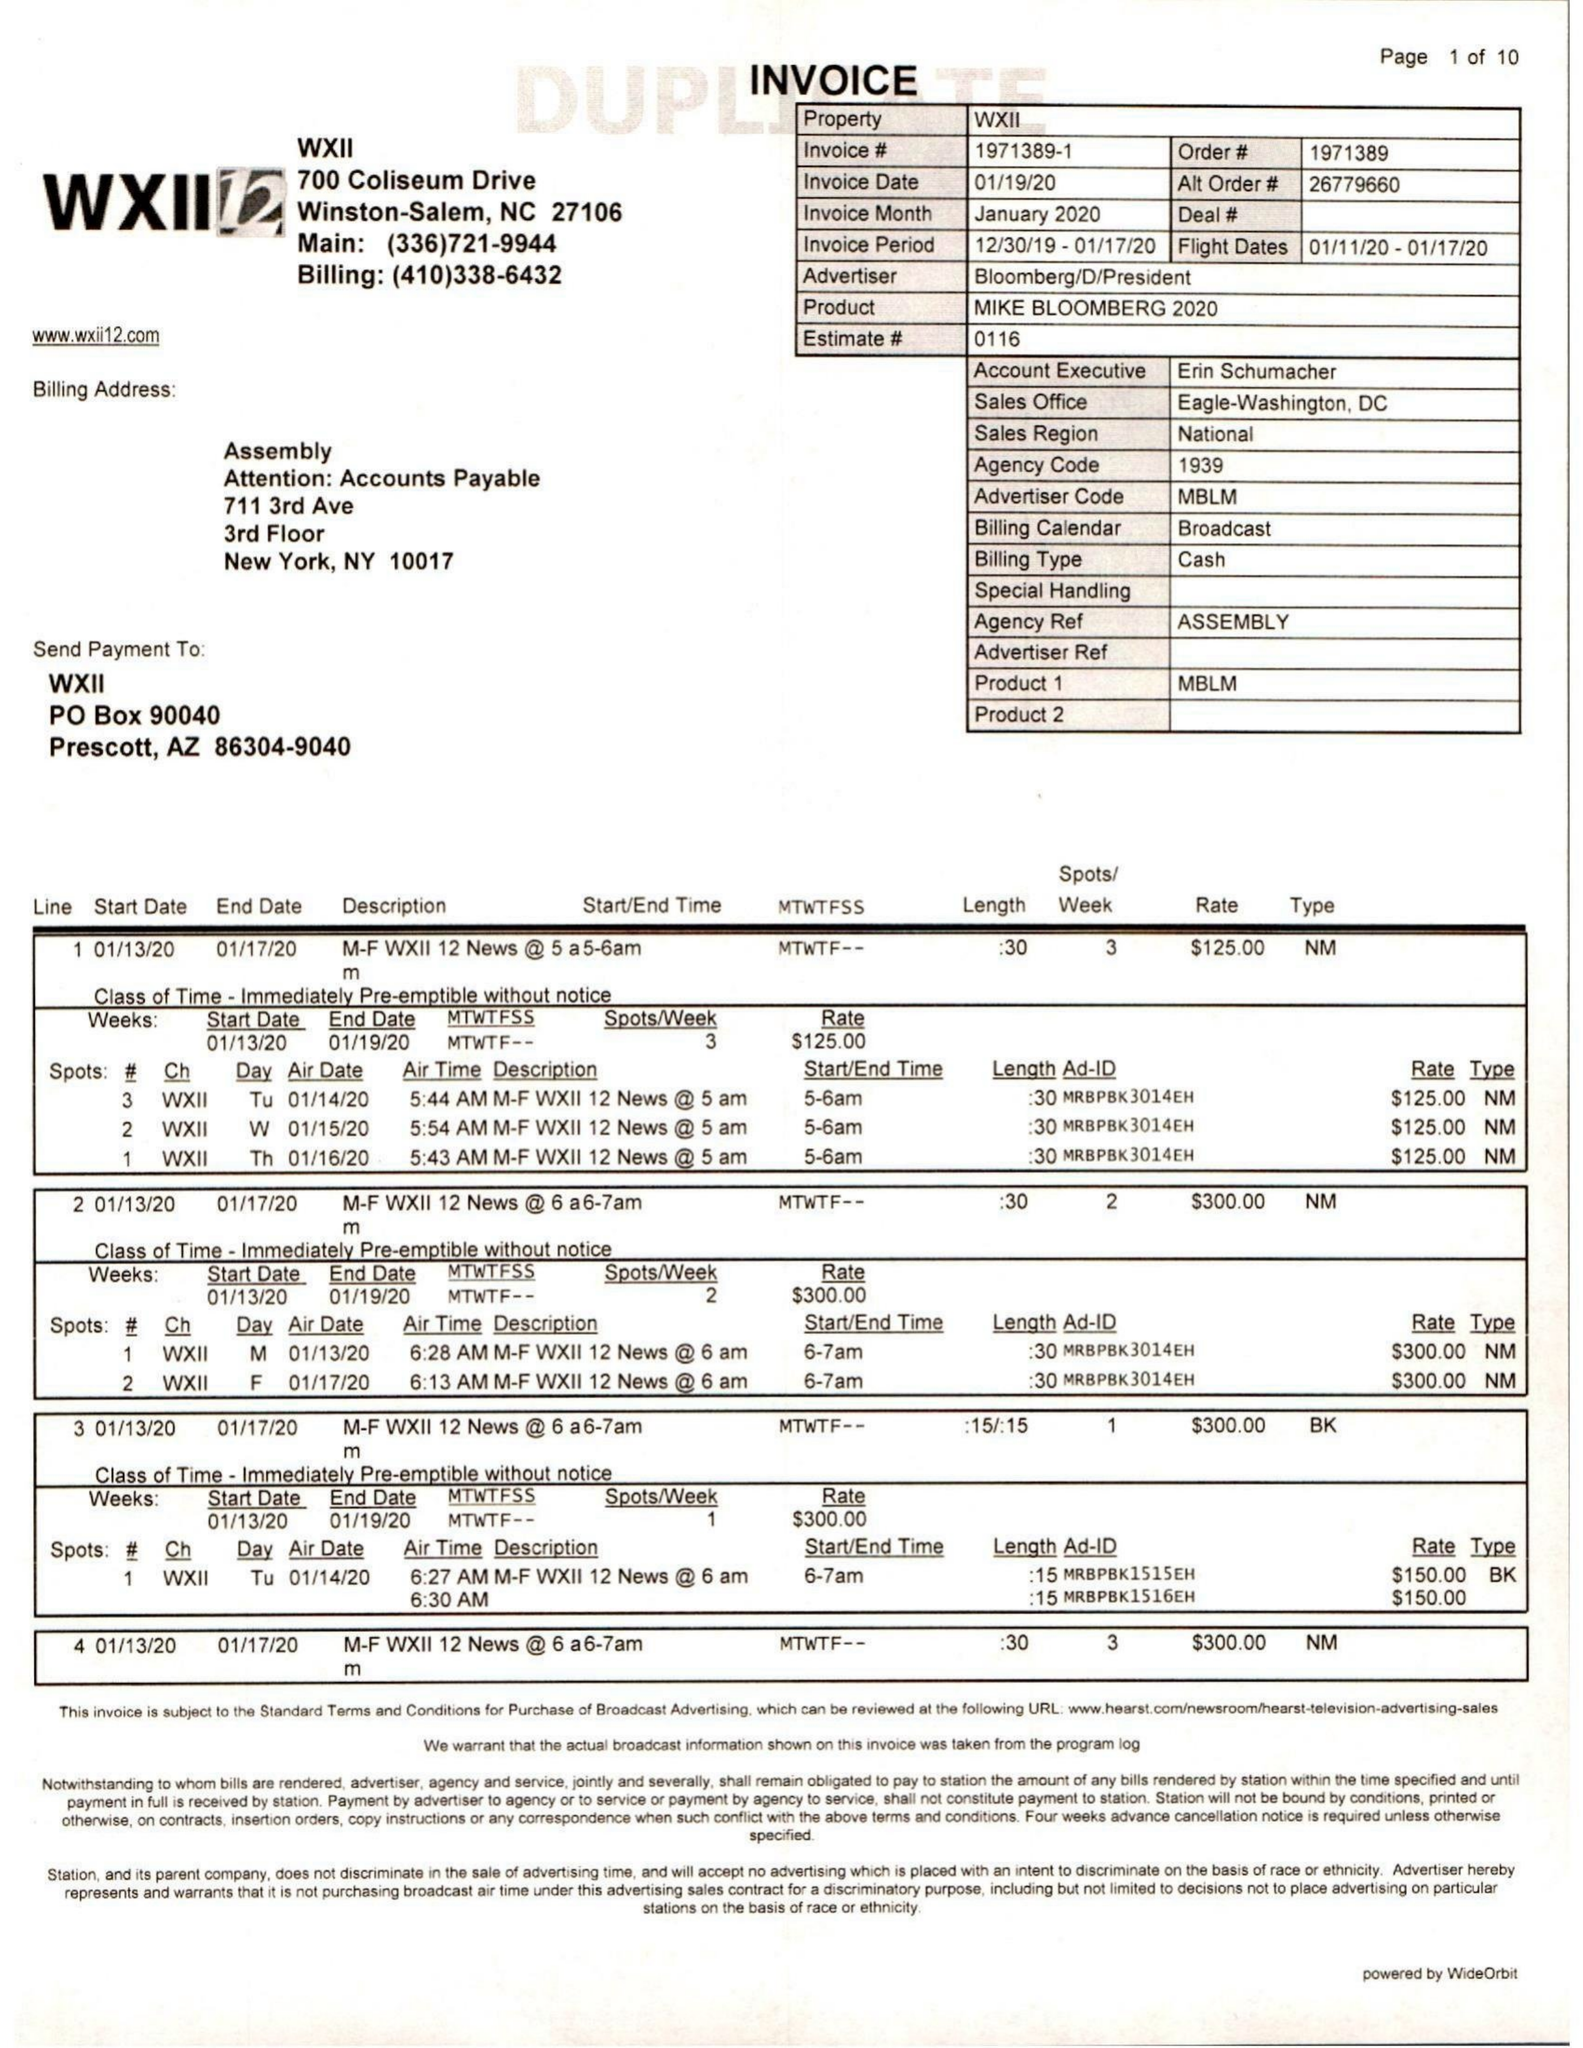What is the value for the contract_num?
Answer the question using a single word or phrase. 1971389 